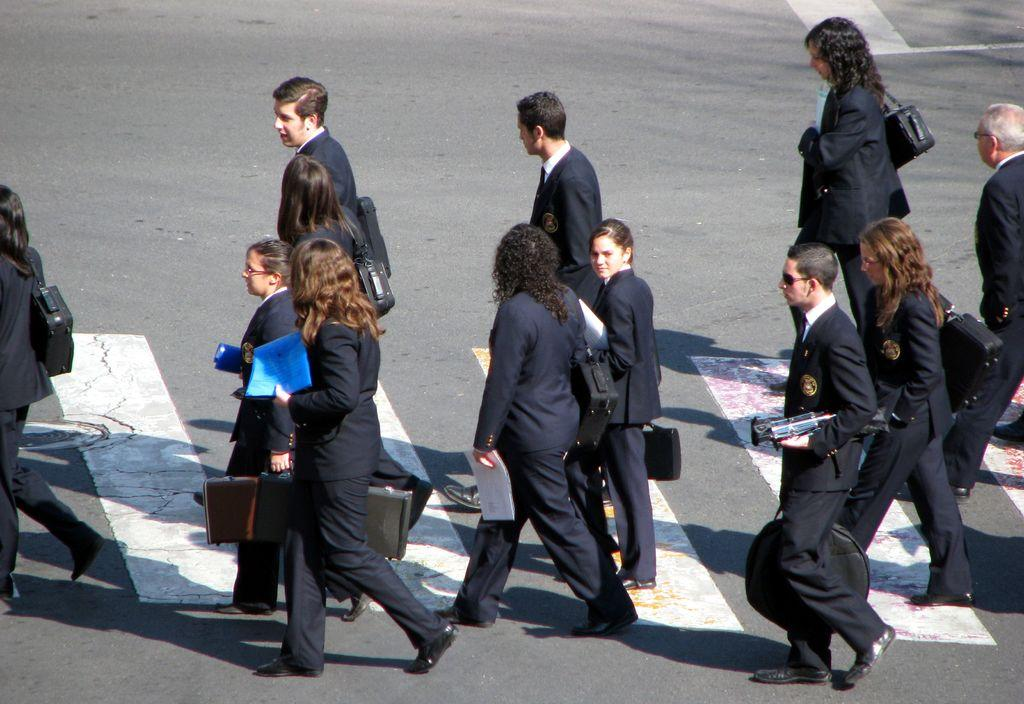What is happening with the group of people in the image? The people are walking on the road in the image. What feature is present in the image to help people cross the road safely? There is a pedestrian crossing in the image. Can you describe what some of the people in the group are holding? Some people in the group are holding objects. What are the people wearing that might be used to carry items? Some people are wearing bags. What type of cake is being served at the pedestrian crossing in the image? There is no cake present in the image; it features a group of people walking on the road and a pedestrian crossing. 